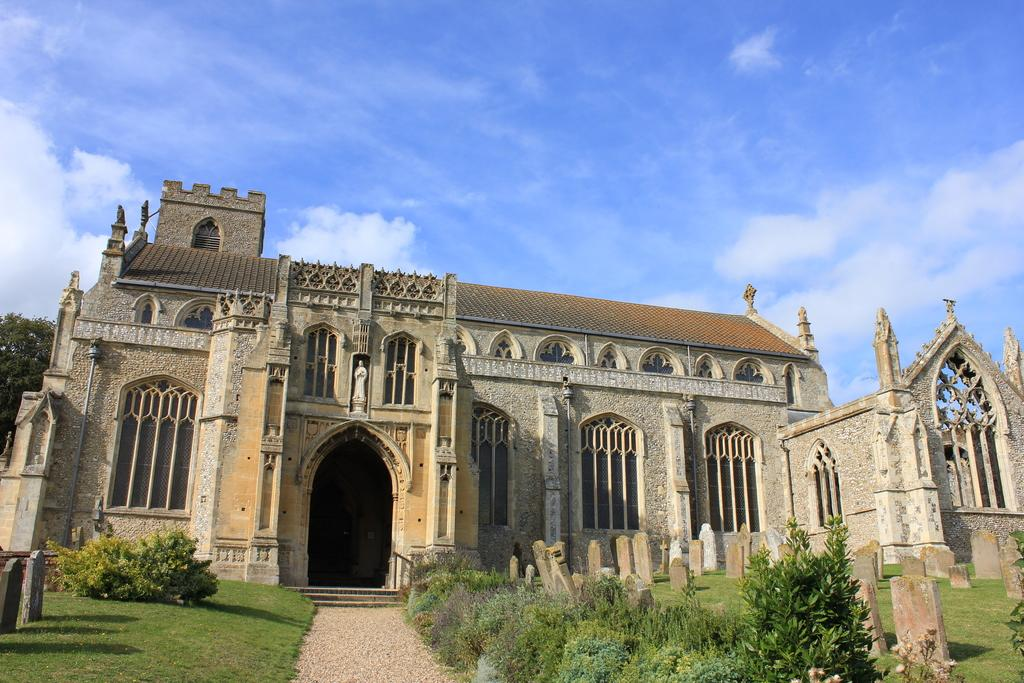What type of structure is in the image? There is a fort in the image. What is located in front of the fort? Grass, bushes, and plants are visible in front of the fort. What can be seen at the top of the image? The sky is visible at the top of the image. What time does the clock on the fort show in the image? There is no clock present in the image, so it is not possible to determine the time. 